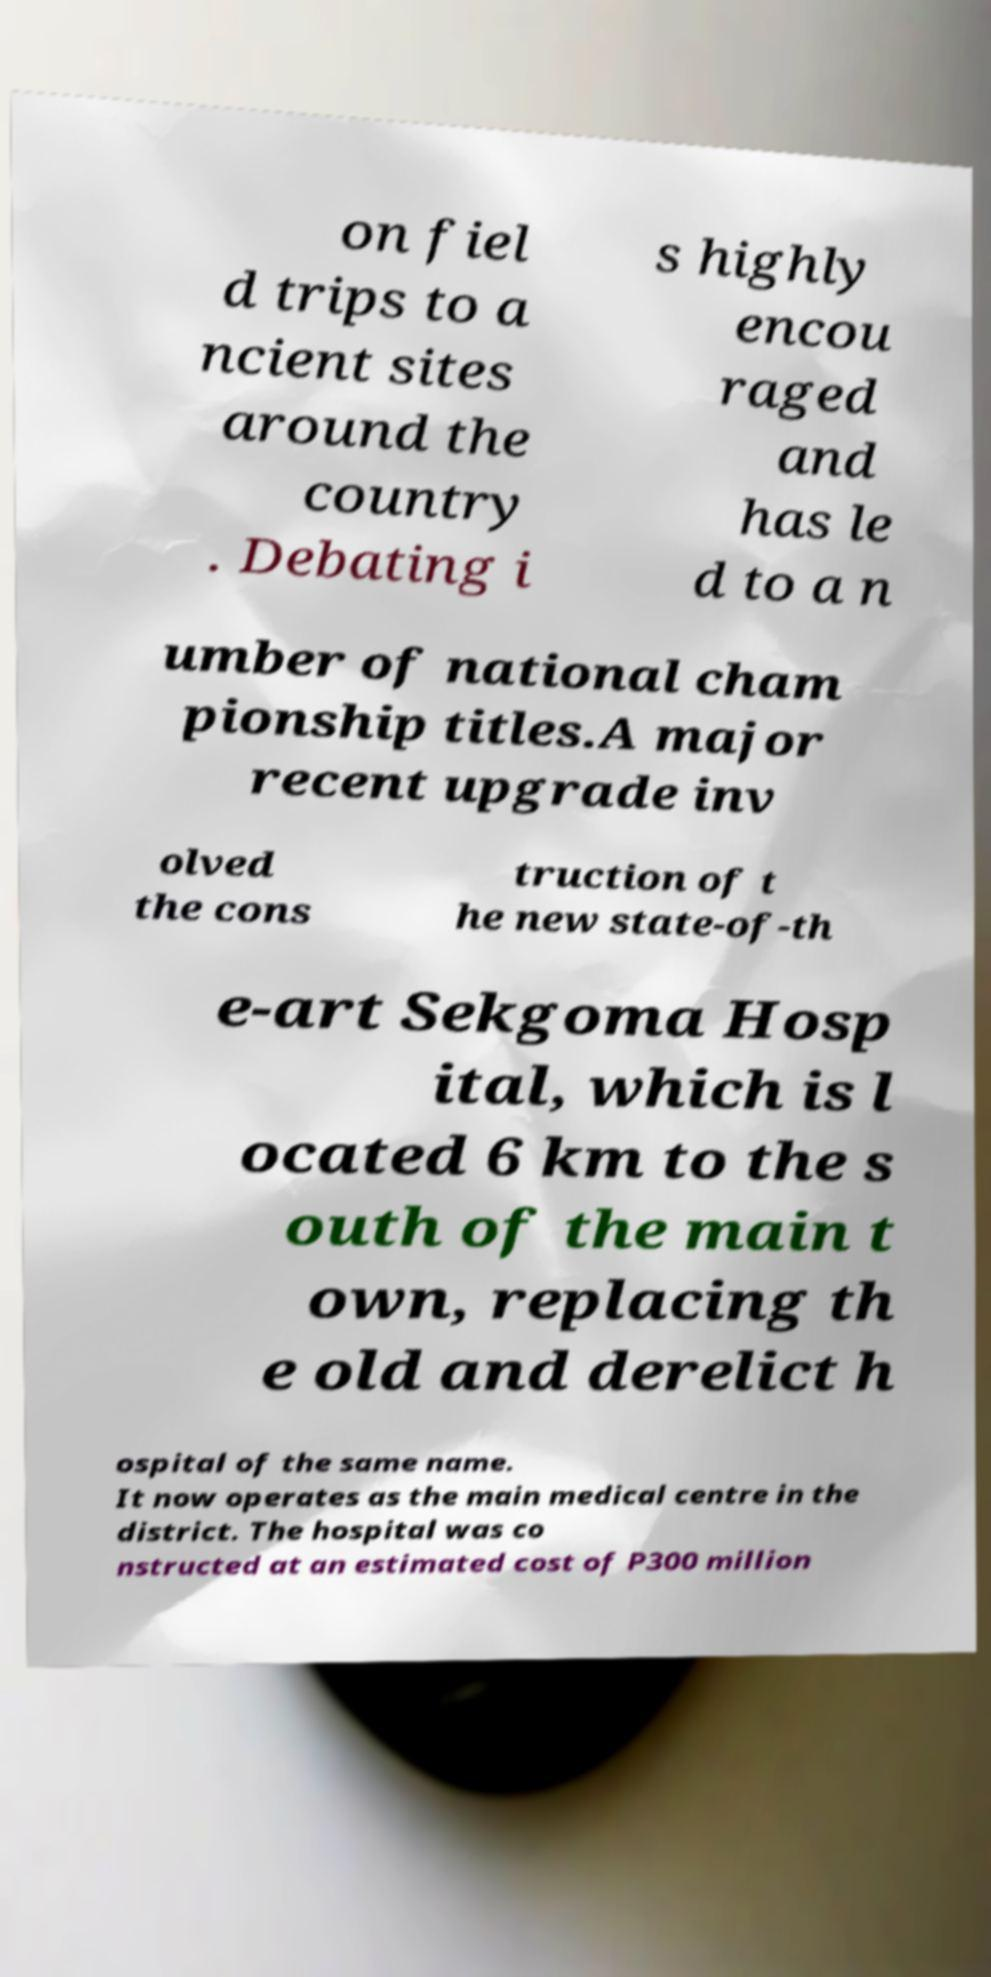Can you read and provide the text displayed in the image?This photo seems to have some interesting text. Can you extract and type it out for me? on fiel d trips to a ncient sites around the country . Debating i s highly encou raged and has le d to a n umber of national cham pionship titles.A major recent upgrade inv olved the cons truction of t he new state-of-th e-art Sekgoma Hosp ital, which is l ocated 6 km to the s outh of the main t own, replacing th e old and derelict h ospital of the same name. It now operates as the main medical centre in the district. The hospital was co nstructed at an estimated cost of P300 million 